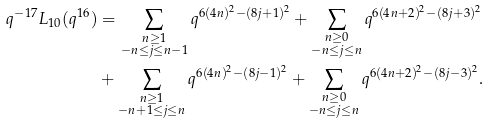Convert formula to latex. <formula><loc_0><loc_0><loc_500><loc_500>q ^ { - 1 7 } L _ { 1 0 } ( q ^ { 1 6 } ) & = \sum _ { \substack { n \geq 1 \\ - n \leq j \leq n - 1 } } q ^ { 6 ( 4 n ) ^ { 2 } - ( 8 j + 1 ) ^ { 2 } } + \sum _ { \substack { n \geq 0 \\ - n \leq j \leq n } } q ^ { 6 ( 4 n + 2 ) ^ { 2 } - ( 8 j + 3 ) ^ { 2 } } \\ & + \sum _ { \substack { n \geq 1 \\ - n + 1 \leq j \leq n } } q ^ { 6 ( 4 n ) ^ { 2 } - ( 8 j - 1 ) ^ { 2 } } + \sum _ { \substack { n \geq 0 \\ - n \leq j \leq n } } q ^ { 6 ( 4 n + 2 ) ^ { 2 } - ( 8 j - 3 ) ^ { 2 } } .</formula> 